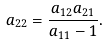<formula> <loc_0><loc_0><loc_500><loc_500>a _ { 2 2 } = \frac { a _ { 1 2 } a _ { 2 1 } } { a _ { 1 1 } - 1 } .</formula> 